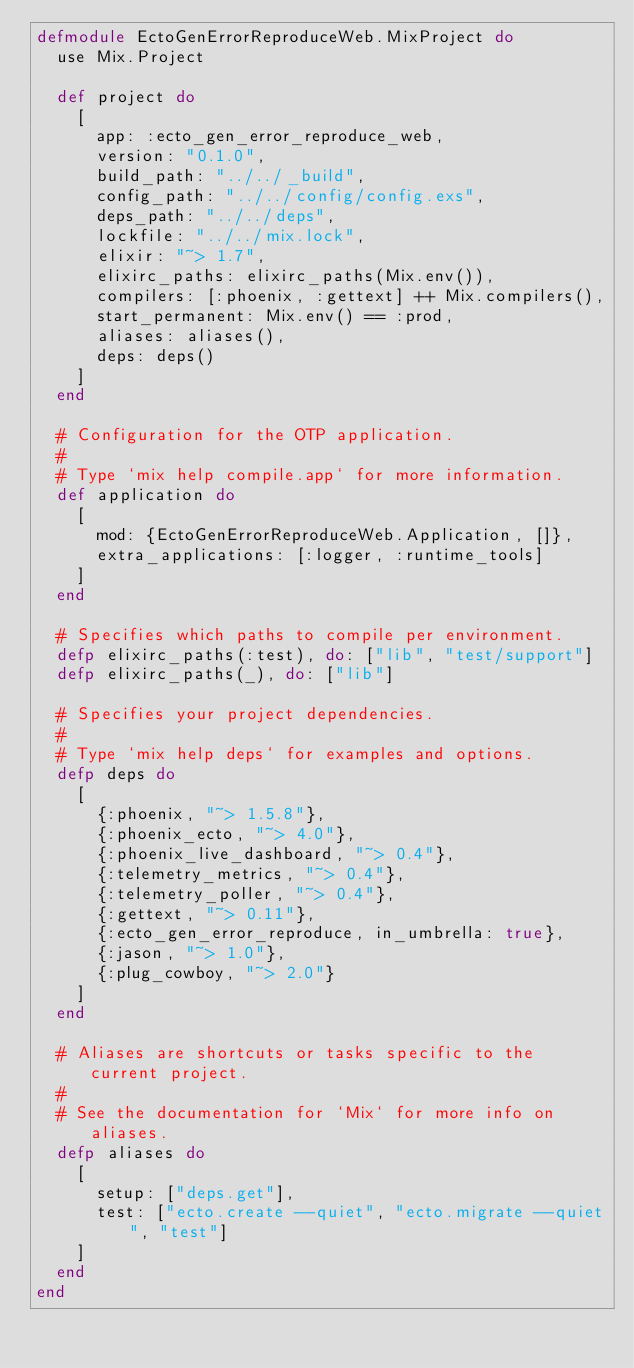<code> <loc_0><loc_0><loc_500><loc_500><_Elixir_>defmodule EctoGenErrorReproduceWeb.MixProject do
  use Mix.Project

  def project do
    [
      app: :ecto_gen_error_reproduce_web,
      version: "0.1.0",
      build_path: "../../_build",
      config_path: "../../config/config.exs",
      deps_path: "../../deps",
      lockfile: "../../mix.lock",
      elixir: "~> 1.7",
      elixirc_paths: elixirc_paths(Mix.env()),
      compilers: [:phoenix, :gettext] ++ Mix.compilers(),
      start_permanent: Mix.env() == :prod,
      aliases: aliases(),
      deps: deps()
    ]
  end

  # Configuration for the OTP application.
  #
  # Type `mix help compile.app` for more information.
  def application do
    [
      mod: {EctoGenErrorReproduceWeb.Application, []},
      extra_applications: [:logger, :runtime_tools]
    ]
  end

  # Specifies which paths to compile per environment.
  defp elixirc_paths(:test), do: ["lib", "test/support"]
  defp elixirc_paths(_), do: ["lib"]

  # Specifies your project dependencies.
  #
  # Type `mix help deps` for examples and options.
  defp deps do
    [
      {:phoenix, "~> 1.5.8"},
      {:phoenix_ecto, "~> 4.0"},
      {:phoenix_live_dashboard, "~> 0.4"},
      {:telemetry_metrics, "~> 0.4"},
      {:telemetry_poller, "~> 0.4"},
      {:gettext, "~> 0.11"},
      {:ecto_gen_error_reproduce, in_umbrella: true},
      {:jason, "~> 1.0"},
      {:plug_cowboy, "~> 2.0"}
    ]
  end

  # Aliases are shortcuts or tasks specific to the current project.
  #
  # See the documentation for `Mix` for more info on aliases.
  defp aliases do
    [
      setup: ["deps.get"],
      test: ["ecto.create --quiet", "ecto.migrate --quiet", "test"]
    ]
  end
end
</code> 